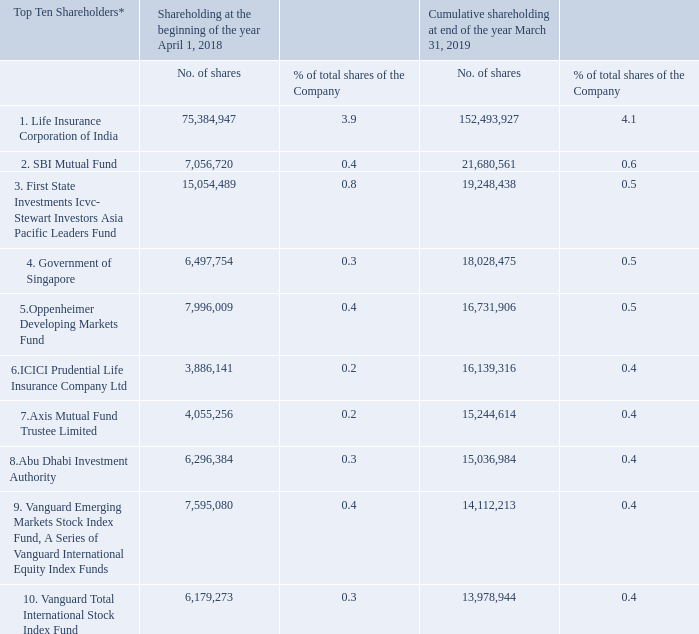Iv) shareholding pattern of top ten shareholders (other than directors, promoters and holder of gdrs and adrs):
* the shares of the company are traded on daily basis and hence the datewise increase/decrease in shareholding is not indicated. shareholding is consolidated based on permanent account number (pan) of the shareholder.
what information does the table provide? Shareholding pattern of top ten shareholders. Why are datewise changes in shareholding not indicated? Shares of the company are traded on daily basis. On what basis is shareholding consolidated? Shareholding is consolidated based on permanent account number (pan) of the shareholder. Based on the percentage shareholding of Life Insurance Corporation of India, what is the total number of shares outstanding at the beginning of the year, April 1 2018? 75,384,947/3.9% 
Answer: 1932947358.97. At end of the year March 31 2019, what is the total cumulative percentage shareholding of all the top ten shareholders?
Answer scale should be: percent. 4.1+0.6+0.5+0.5+0.5+0.4+0.4+0.4+0.4+0.4 
Answer: 8.2. At end of the year March 31 2019, how many cumulative shares do the top ten shareholders hold in total? 152,493,927+21,680,561+19,248,438+18,028,475+16,731,906+16,139,316+15,244,614+15,036,984+14,112,213+13,978,944 
Answer: 302695378. 